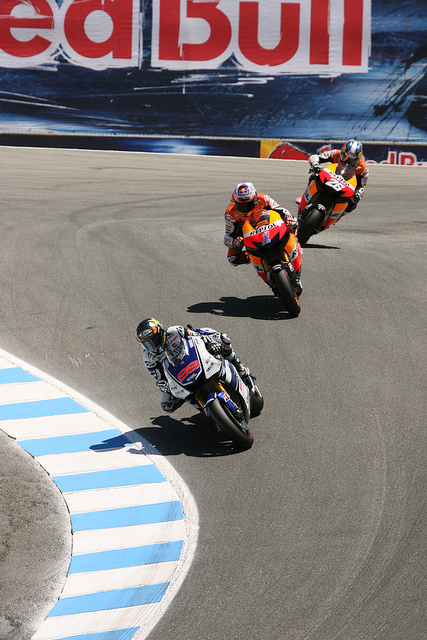Please identify all text content in this image. 26 eaBull 